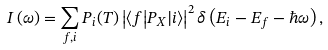Convert formula to latex. <formula><loc_0><loc_0><loc_500><loc_500>I \left ( \omega \right ) = \sum _ { f , i } P _ { i } ( T ) \left | { \left \langle f \right | } P _ { X } { \left | i \right \rangle } \right | ^ { 2 } \delta \left ( E _ { i } - E _ { f } - \hbar { \omega } \right ) ,</formula> 